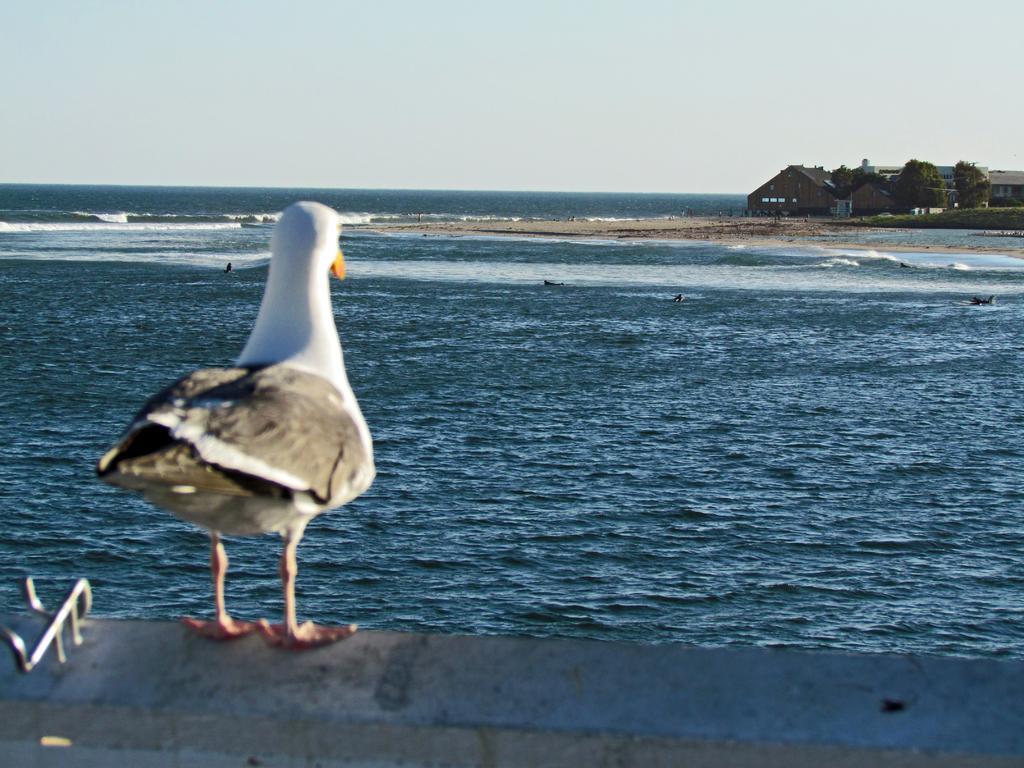How would you summarize this image in a sentence or two? In this picture I can observe a bird on the left side. On the right side I can observe houses. In the background there is an ocean and sky. 